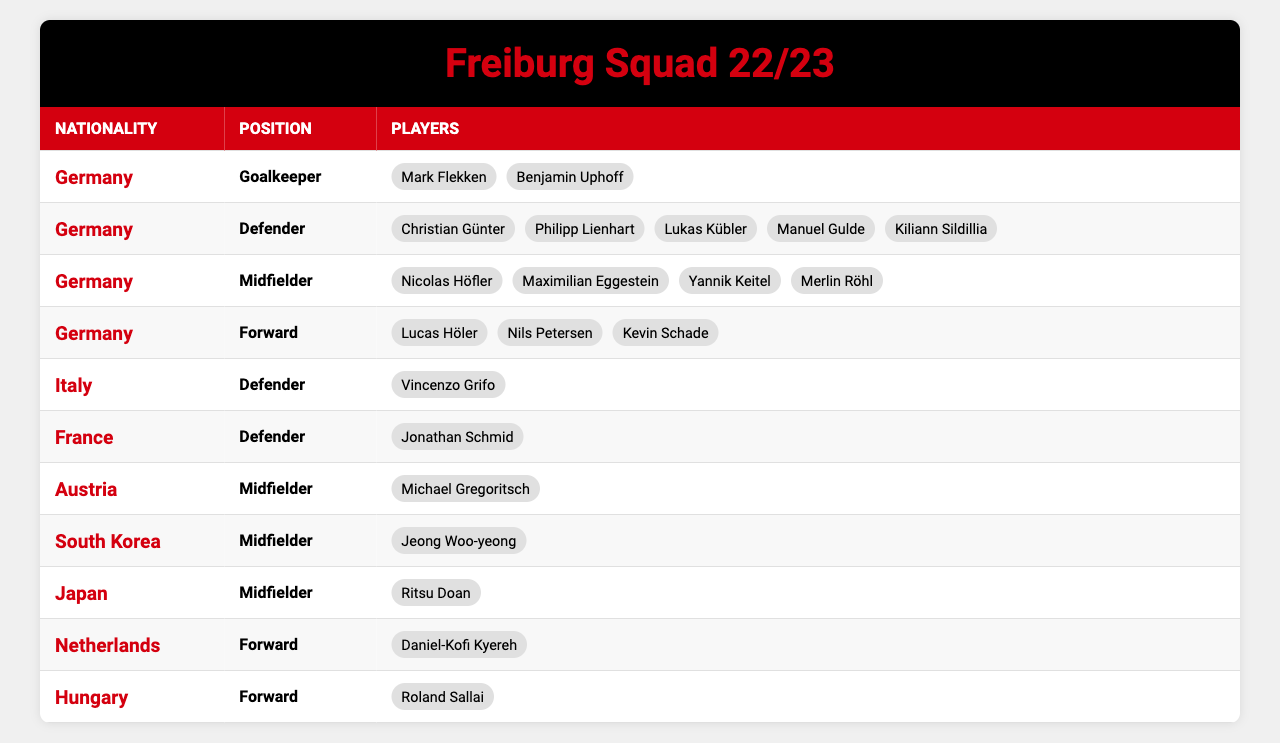What is the total number of players in Freiburg's 22/23 squad? By counting all the players listed in each position and nationality, we have a total of 21 players (2 Goalkeepers, 5 Defenders, 4 Midfielders, 3 Forwards from Germany, plus 1 Defender from Italy, 1 Defender from France, 1 Midfielder from Austria, 1 Midfielder from South Korea, 1 Midfielder from Japan, 1 Forward from the Netherlands, and 1 Forward from Hungary). Thus, 2 + 5 + 4 + 3 + 1 + 1 + 1 + 1 + 1 + 1 = 21.
Answer: 21 How many midfielders are in Freiburg's squad? To find the total number of midfielders, we need to add the midfielders from each nationality: 4 from Germany, 1 from Austria, 1 from South Korea, and 1 from Japan, totaling 4 + 1 + 1 + 1 = 7.
Answer: 7 Which nationality contributes the highest number of players? Upon reviewing the table, Germany has the highest number with 14 players (2 Goalkeepers, 5 Defenders, 4 Midfielders, and 3 Forwards). Other nationalities have fewer players.
Answer: Germany Does Freiburg have any players from Spain in the squad? There are no players listed from Spain in any of the nationalities displayed in the table. Thus, the answer is no.
Answer: No How many forwards are there from non-German nationalities? Checking the forwards who are not German, we find 1 from the Netherlands (Daniel-Kofi Kyereh) and 1 from Hungary (Roland Sallai), which totals to 1 + 1 = 2 forwards.
Answer: 2 What is the ratio of goalkeepers to defenders in Freiburg's squad? The squad has 2 goalkeepers and 5 defenders. The ratio of goalkeepers to defenders is 2:5. This represents a straightforward comparison of their quantities without any additional calculations.
Answer: 2:5 Which position has the least number of players, and how many are there? Looking at the table, the position with the least number of players is 'Italy' with only 1 Defender (Vincenzo Grifo). No other positions/nationalities have fewer than 1 player. Thus, the answer is 1 for the Defender position.
Answer: 1 How many different nationalities are represented in Freiburg's squad? There are 7 different nationalities listed in the table: Germany, Italy, France, Austria, South Korea, Japan, Netherlands, and Hungary, which totals to 7.
Answer: 7 Are there more defenders or forwards in Freiburg's squad? For defenders, there are 5 listed (Germany: 5, Italy: 1, France: 1). Forwards have a total of 3 from Germany and 2 from other nationalities, which adds up to 5 in total. Thus, both positions have an equal number of players.
Answer: Equal (5 each) 